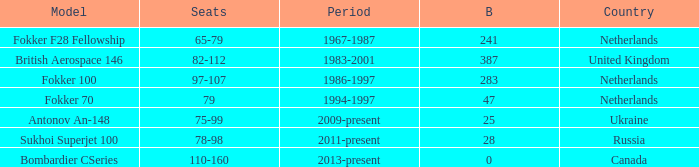Between which years were there 241 fokker 70 model cabins built? 1994-1997. 